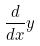<formula> <loc_0><loc_0><loc_500><loc_500>\frac { d } { d x } y</formula> 